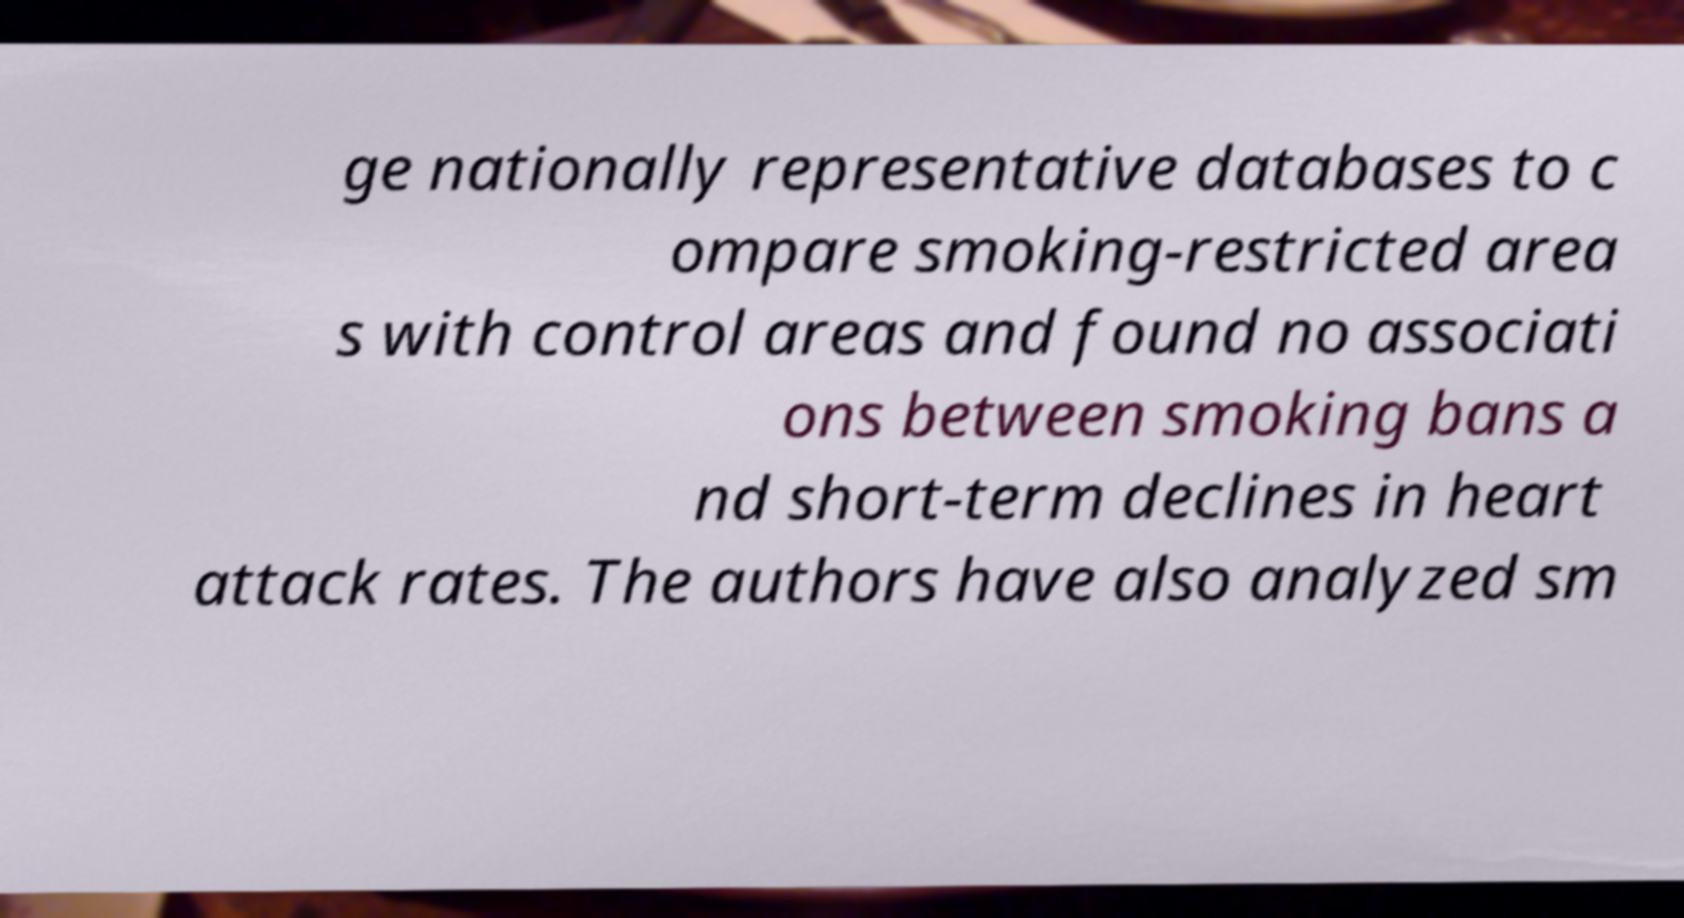Please identify and transcribe the text found in this image. ge nationally representative databases to c ompare smoking-restricted area s with control areas and found no associati ons between smoking bans a nd short-term declines in heart attack rates. The authors have also analyzed sm 